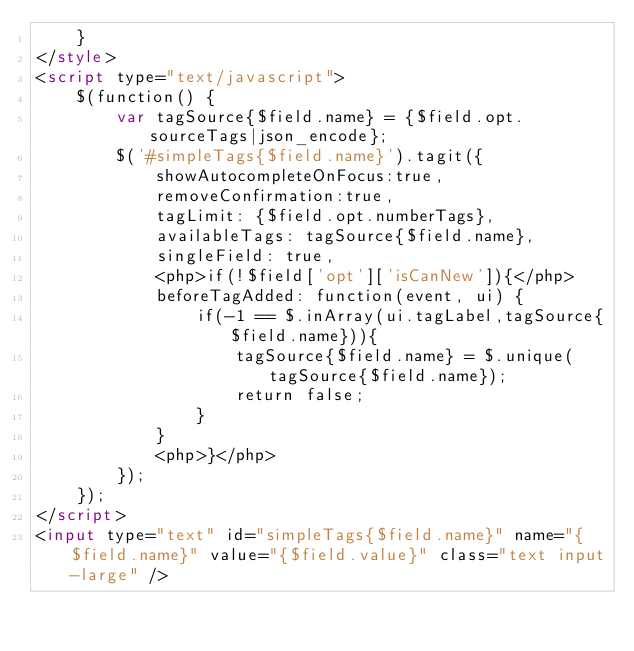Convert code to text. <code><loc_0><loc_0><loc_500><loc_500><_HTML_>    }
</style>
<script type="text/javascript">
    $(function() {
        var tagSource{$field.name} = {$field.opt.sourceTags|json_encode};
        $('#simpleTags{$field.name}').tagit({
            showAutocompleteOnFocus:true,
            removeConfirmation:true,
            tagLimit: {$field.opt.numberTags},
            availableTags: tagSource{$field.name},
            singleField: true,
            <php>if(!$field['opt']['isCanNew']){</php>
            beforeTagAdded: function(event, ui) {
                if(-1 == $.inArray(ui.tagLabel,tagSource{$field.name})){
                    tagSource{$field.name} = $.unique(tagSource{$field.name});
                    return false;
                }
            }
            <php>}</php>
        });
    });
</script>
<input type="text" id="simpleTags{$field.name}" name="{$field.name}" value="{$field.value}" class="text input-large" /></code> 